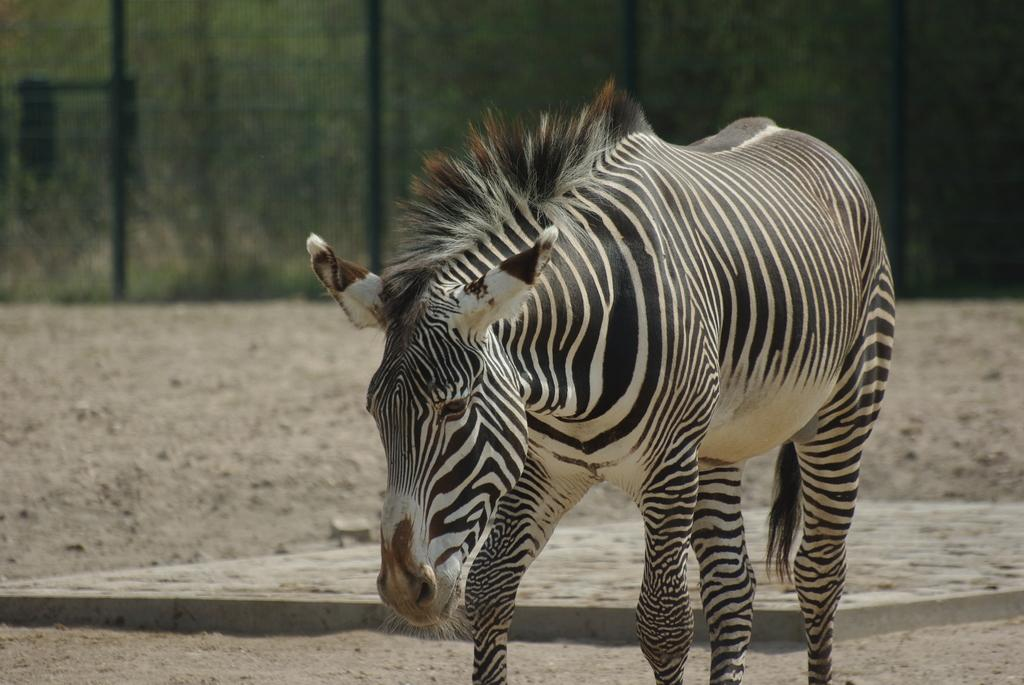What animal is present in the image? There is a zebra in the image. What is the zebra doing in the image? The zebra is walking on the ground. What can be seen in the background of the image? There is a net fencing and plants visible in the background of the image. What type of company is the zebra working for in the image? There is no indication in the image that the zebra is working for a company, as it is simply walking on the ground. 